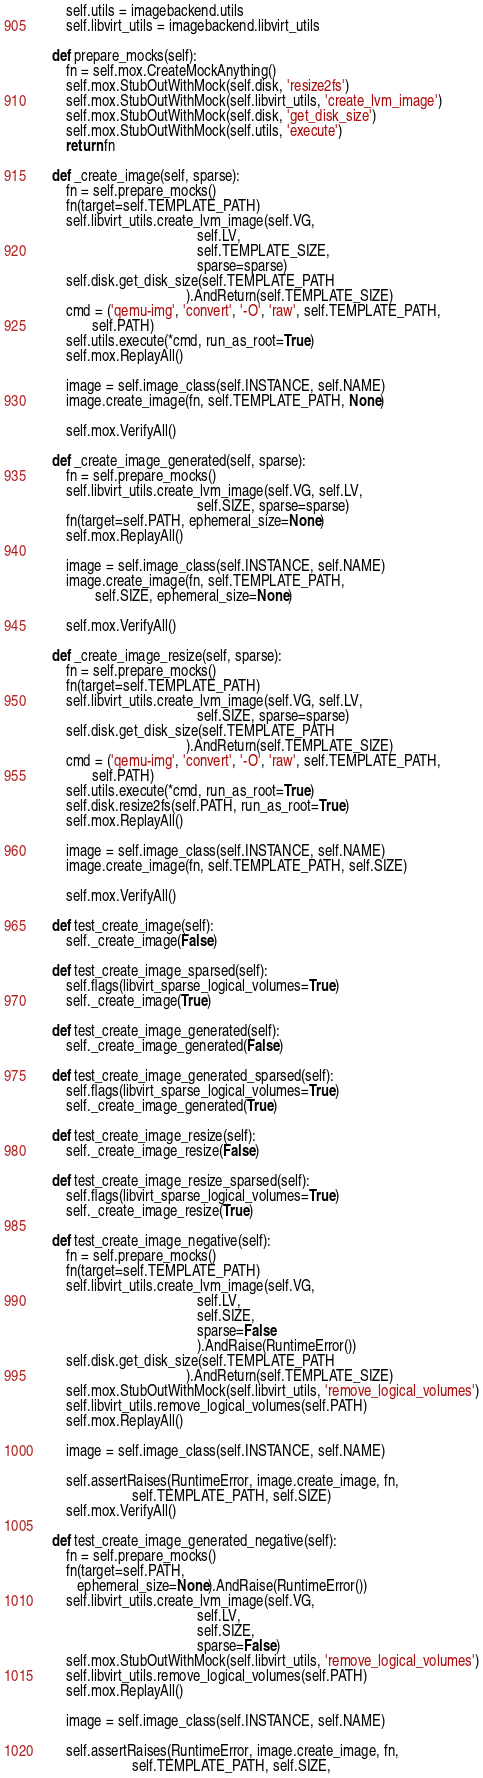<code> <loc_0><loc_0><loc_500><loc_500><_Python_>        self.utils = imagebackend.utils
        self.libvirt_utils = imagebackend.libvirt_utils

    def prepare_mocks(self):
        fn = self.mox.CreateMockAnything()
        self.mox.StubOutWithMock(self.disk, 'resize2fs')
        self.mox.StubOutWithMock(self.libvirt_utils, 'create_lvm_image')
        self.mox.StubOutWithMock(self.disk, 'get_disk_size')
        self.mox.StubOutWithMock(self.utils, 'execute')
        return fn

    def _create_image(self, sparse):
        fn = self.prepare_mocks()
        fn(target=self.TEMPLATE_PATH)
        self.libvirt_utils.create_lvm_image(self.VG,
                                            self.LV,
                                            self.TEMPLATE_SIZE,
                                            sparse=sparse)
        self.disk.get_disk_size(self.TEMPLATE_PATH
                                         ).AndReturn(self.TEMPLATE_SIZE)
        cmd = ('qemu-img', 'convert', '-O', 'raw', self.TEMPLATE_PATH,
               self.PATH)
        self.utils.execute(*cmd, run_as_root=True)
        self.mox.ReplayAll()

        image = self.image_class(self.INSTANCE, self.NAME)
        image.create_image(fn, self.TEMPLATE_PATH, None)

        self.mox.VerifyAll()

    def _create_image_generated(self, sparse):
        fn = self.prepare_mocks()
        self.libvirt_utils.create_lvm_image(self.VG, self.LV,
                                            self.SIZE, sparse=sparse)
        fn(target=self.PATH, ephemeral_size=None)
        self.mox.ReplayAll()

        image = self.image_class(self.INSTANCE, self.NAME)
        image.create_image(fn, self.TEMPLATE_PATH,
                self.SIZE, ephemeral_size=None)

        self.mox.VerifyAll()

    def _create_image_resize(self, sparse):
        fn = self.prepare_mocks()
        fn(target=self.TEMPLATE_PATH)
        self.libvirt_utils.create_lvm_image(self.VG, self.LV,
                                            self.SIZE, sparse=sparse)
        self.disk.get_disk_size(self.TEMPLATE_PATH
                                         ).AndReturn(self.TEMPLATE_SIZE)
        cmd = ('qemu-img', 'convert', '-O', 'raw', self.TEMPLATE_PATH,
               self.PATH)
        self.utils.execute(*cmd, run_as_root=True)
        self.disk.resize2fs(self.PATH, run_as_root=True)
        self.mox.ReplayAll()

        image = self.image_class(self.INSTANCE, self.NAME)
        image.create_image(fn, self.TEMPLATE_PATH, self.SIZE)

        self.mox.VerifyAll()

    def test_create_image(self):
        self._create_image(False)

    def test_create_image_sparsed(self):
        self.flags(libvirt_sparse_logical_volumes=True)
        self._create_image(True)

    def test_create_image_generated(self):
        self._create_image_generated(False)

    def test_create_image_generated_sparsed(self):
        self.flags(libvirt_sparse_logical_volumes=True)
        self._create_image_generated(True)

    def test_create_image_resize(self):
        self._create_image_resize(False)

    def test_create_image_resize_sparsed(self):
        self.flags(libvirt_sparse_logical_volumes=True)
        self._create_image_resize(True)

    def test_create_image_negative(self):
        fn = self.prepare_mocks()
        fn(target=self.TEMPLATE_PATH)
        self.libvirt_utils.create_lvm_image(self.VG,
                                            self.LV,
                                            self.SIZE,
                                            sparse=False
                                            ).AndRaise(RuntimeError())
        self.disk.get_disk_size(self.TEMPLATE_PATH
                                         ).AndReturn(self.TEMPLATE_SIZE)
        self.mox.StubOutWithMock(self.libvirt_utils, 'remove_logical_volumes')
        self.libvirt_utils.remove_logical_volumes(self.PATH)
        self.mox.ReplayAll()

        image = self.image_class(self.INSTANCE, self.NAME)

        self.assertRaises(RuntimeError, image.create_image, fn,
                          self.TEMPLATE_PATH, self.SIZE)
        self.mox.VerifyAll()

    def test_create_image_generated_negative(self):
        fn = self.prepare_mocks()
        fn(target=self.PATH,
           ephemeral_size=None).AndRaise(RuntimeError())
        self.libvirt_utils.create_lvm_image(self.VG,
                                            self.LV,
                                            self.SIZE,
                                            sparse=False)
        self.mox.StubOutWithMock(self.libvirt_utils, 'remove_logical_volumes')
        self.libvirt_utils.remove_logical_volumes(self.PATH)
        self.mox.ReplayAll()

        image = self.image_class(self.INSTANCE, self.NAME)

        self.assertRaises(RuntimeError, image.create_image, fn,
                          self.TEMPLATE_PATH, self.SIZE,</code> 